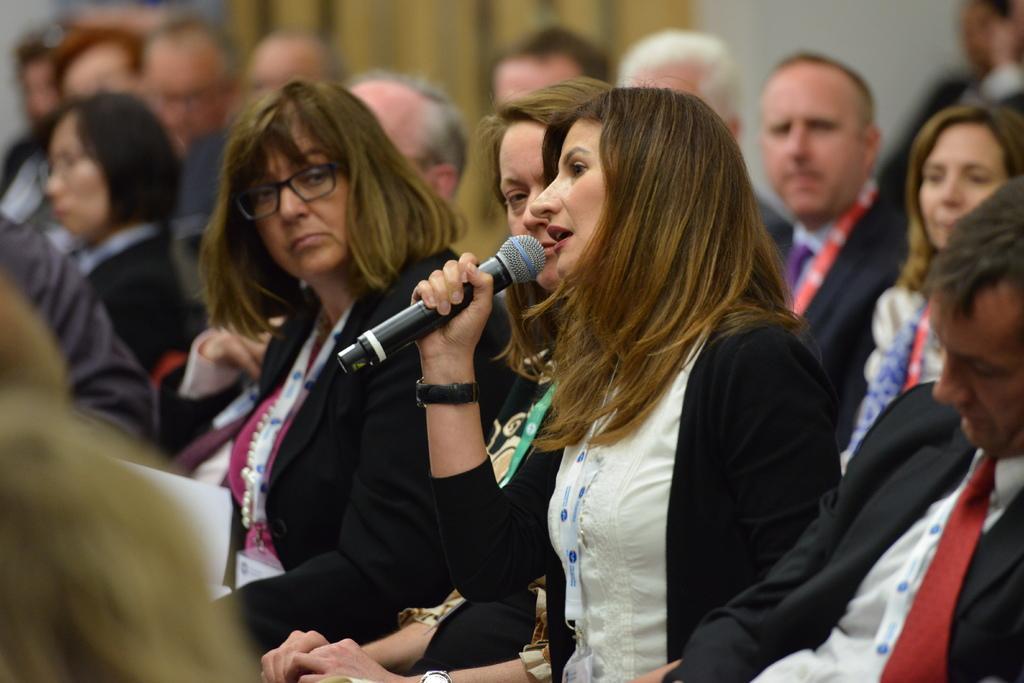Could you give a brief overview of what you see in this image? A group of people are sitting on a chair. The woman in black jacket holding a mic is highlighted. This woman wore spectacles and id card. 